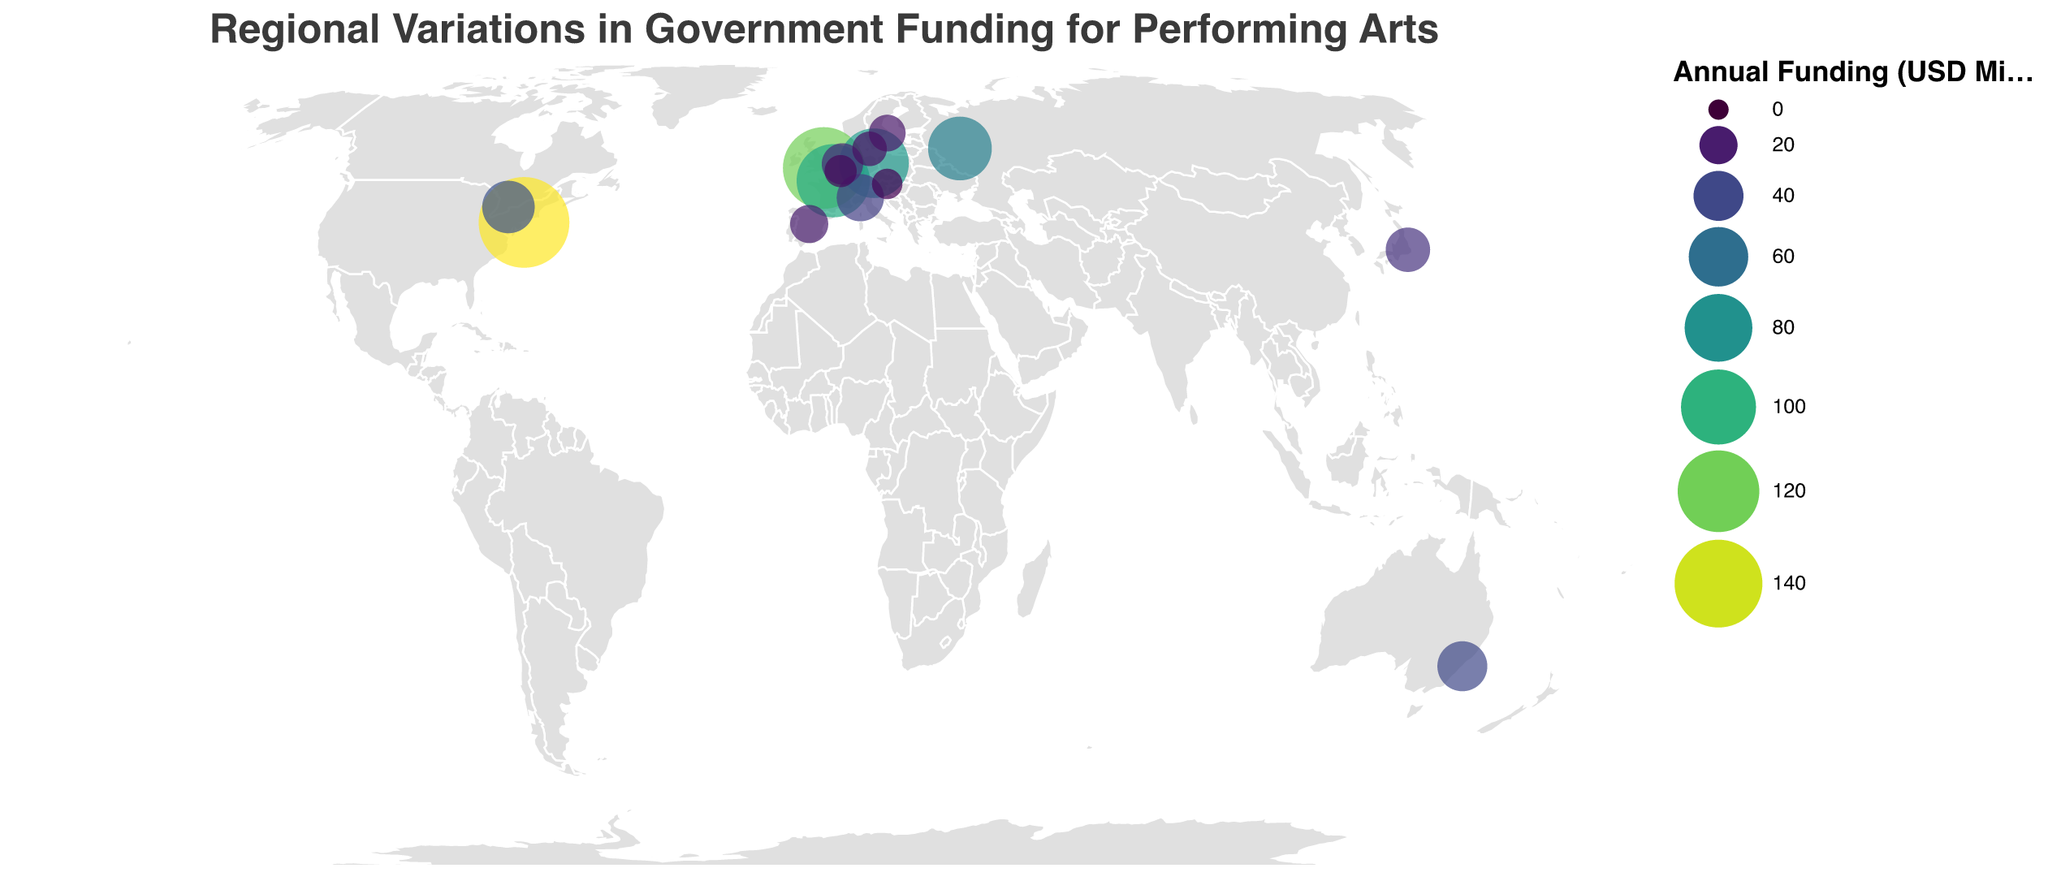What is the title of the plot? The title is displayed at the top of the plot. It reads "Regional Variations in Government Funding for Performing Arts".
Answer: Regional Variations in Government Funding for Performing Arts Which region receives the highest annual government funding for performing arts? The plot shows circles of varying sizes representing funding across different regions. The largest circle corresponds to New York, United States, with the highest funding of $150 million.
Answer: New York, United States Compare the annual government funding between Paris, France, and Vienna, Austria. Which city receives more funding and by how much? Locate Paris and Vienna on the plot. Paris has $95 million and Vienna has $10 million in annual funding. Subtract Vienna's funding from Paris's funding: 95 - 10 = 85.
Answer: Paris receives $85 million more How does the funding in Sydney, Australia compare to that in Toronto, Canada? Identify and compare the sizes of the circles for Sydney and Toronto. Sydney receives $40 million while Toronto receives $45 million.
Answer: Toronto receives $5 million more What is the average annual government funding for performing arts across all the listed regions? Sum all the funding values and divide by the number of regions: (150 + 120 + 95 + 85 + 70 + 45 + 40 + 35 + 30 + 25 + 20 + 18 + 15 + 12 + 10) / 15 = 49.67.
Answer: $49.67 million Identify the region with the smallest annual government funding and provide its amount. Find the smallest circle on the plot which represents Vienna, Austria. The plot details Vienna's funding as $10 million.
Answer: Vienna, $10 million What is the total annual government funding for performing arts in Europe based on the plot? Sum the funding amounts of all the European regions: 120 (London) + 95 (Paris) + 85 (Berlin) + 35 (Milan) + 25 (Amsterdam) + 20 (Madrid) + 18 (Stockholm) + 15 (Copenhagen) + 12 (Brussels) + 10 (Vienna) = 435.
Answer: $435 million 